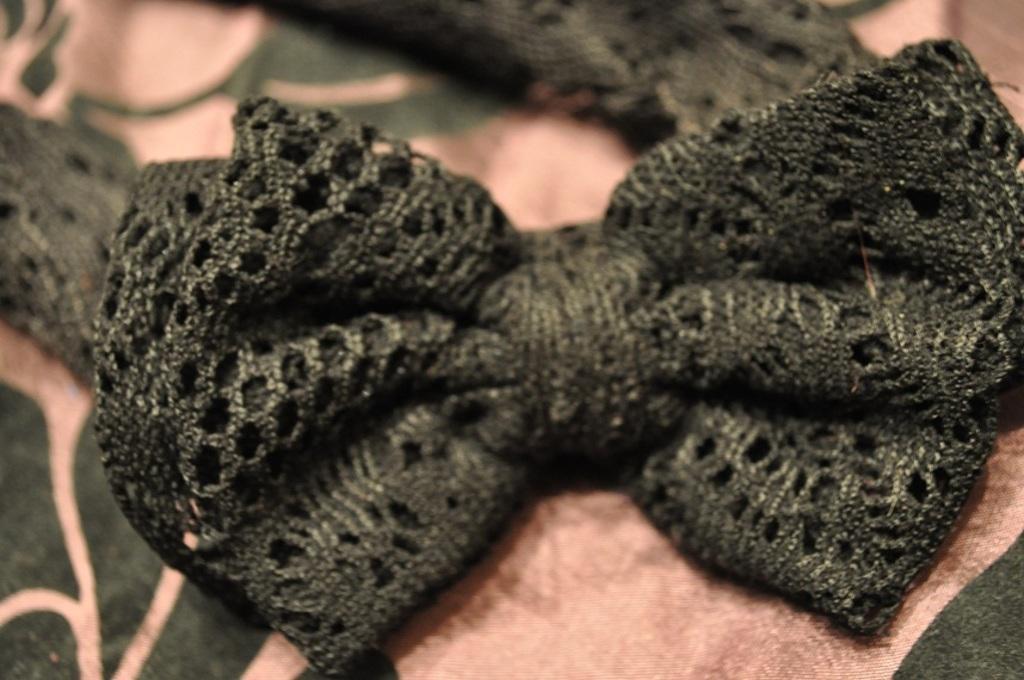In one or two sentences, can you explain what this image depicts? There is a Bow tie as we can see in the middle of this image. 